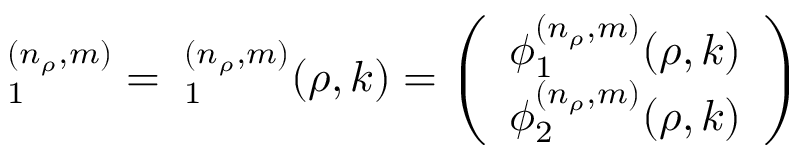<formula> <loc_0><loc_0><loc_500><loc_500>{ \Phi } _ { 1 } ^ { ( n _ { \rho } , m ) } = { \Phi } _ { 1 } ^ { ( n _ { \rho } , m ) } ( \rho , k ) = \left ( \begin{array} { c } { { \phi _ { 1 } ^ { ( n _ { \rho } , m ) } ( \rho , k ) } } \\ { { \phi _ { 2 } ^ { ( n _ { \rho } , m ) } ( \rho , k ) } } \end{array} \right )</formula> 